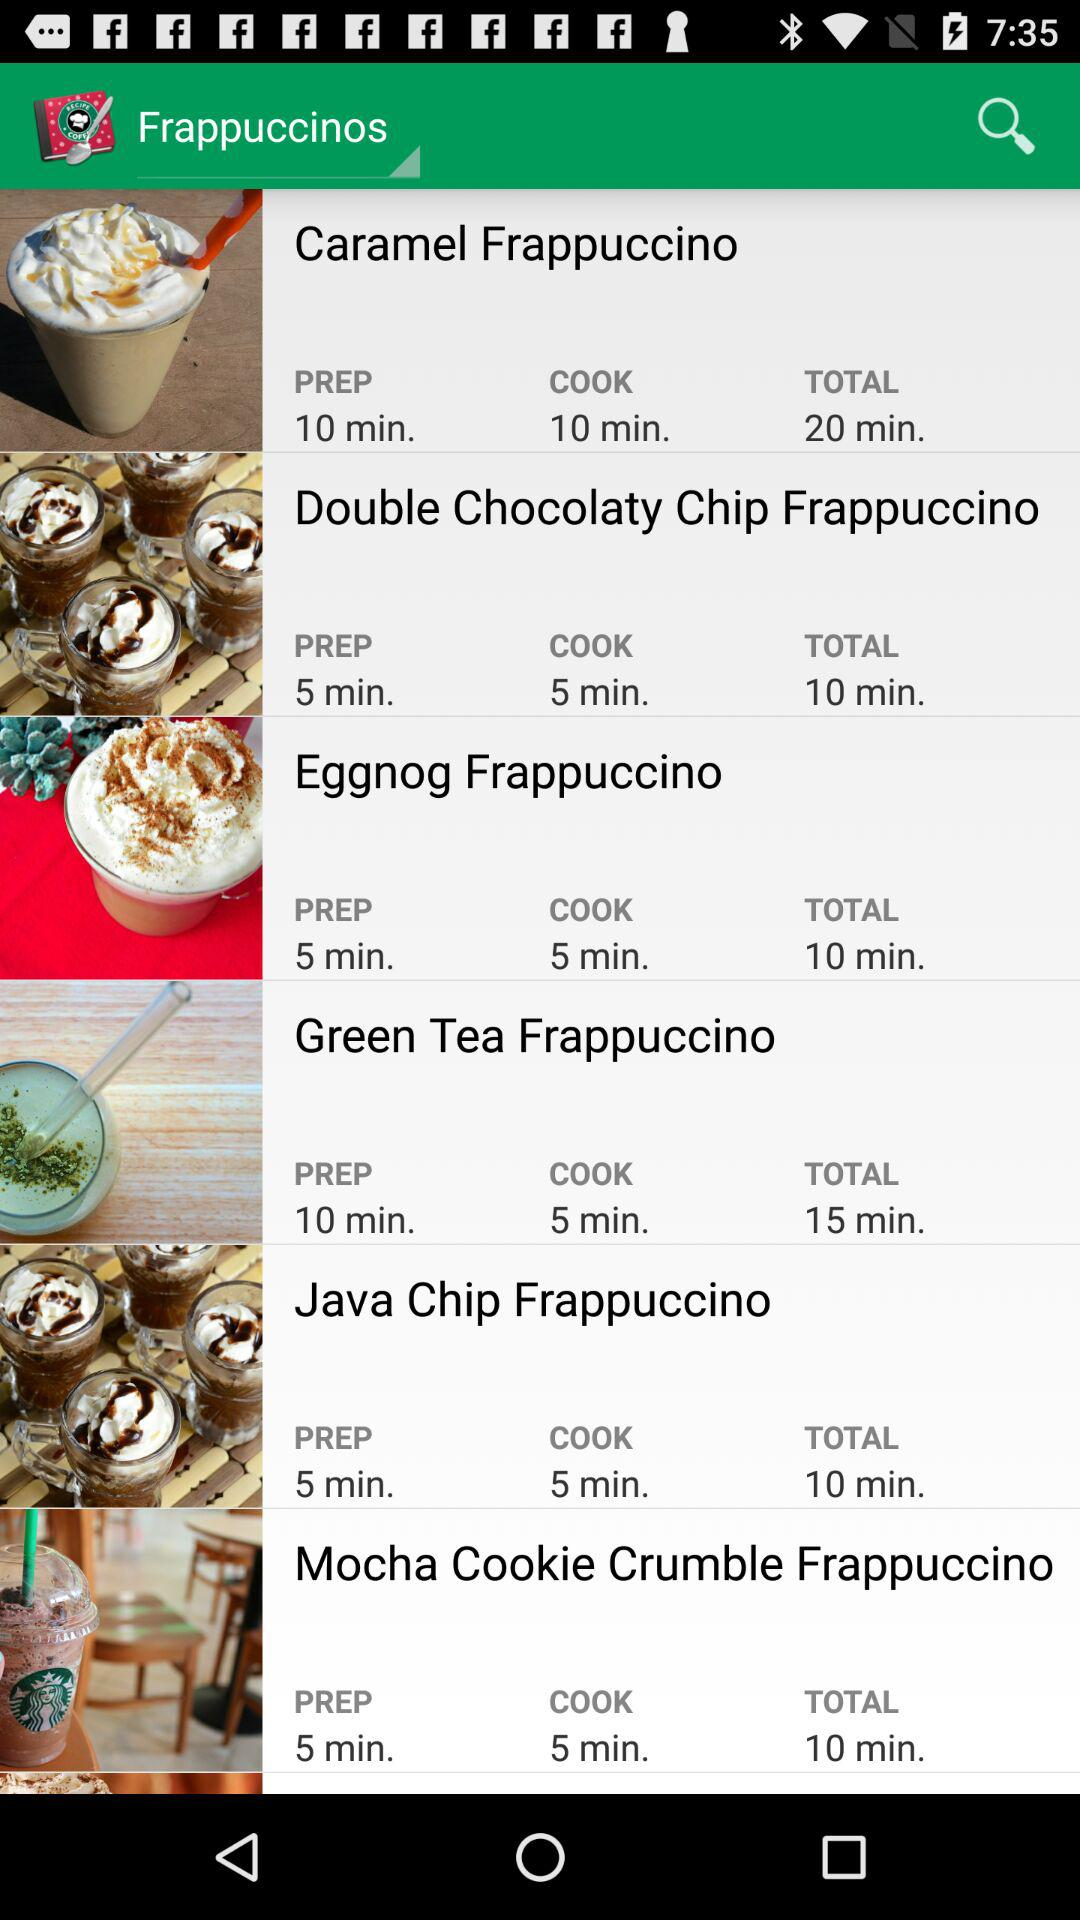How long does it take to cook the "Caramel Frappuccino"? It takes 10 minutes to cook the "Caramel Frappuccino". 